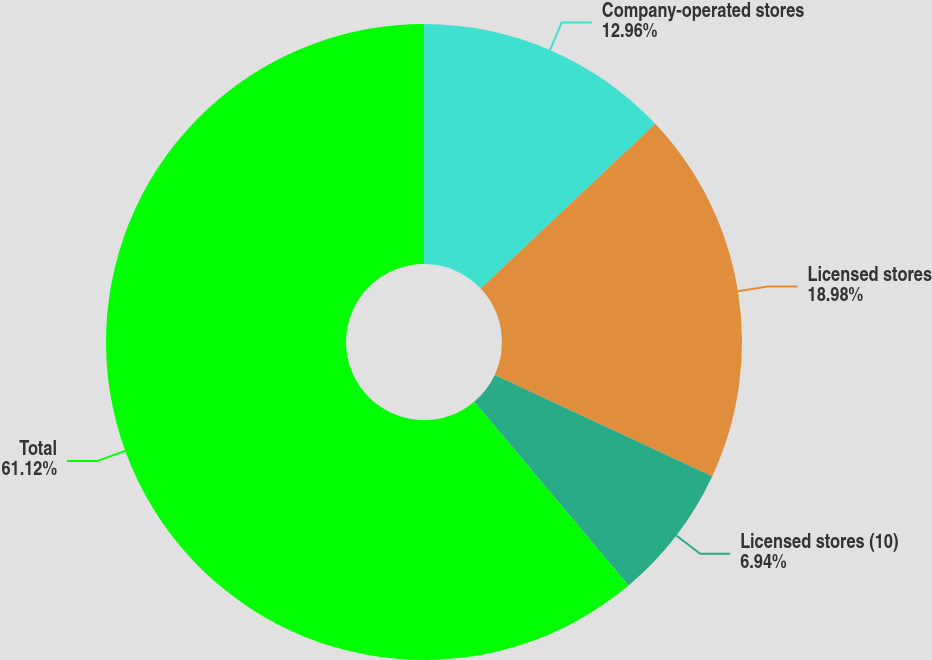Convert chart to OTSL. <chart><loc_0><loc_0><loc_500><loc_500><pie_chart><fcel>Company-operated stores<fcel>Licensed stores<fcel>Licensed stores (10)<fcel>Total<nl><fcel>12.96%<fcel>18.98%<fcel>6.94%<fcel>61.12%<nl></chart> 